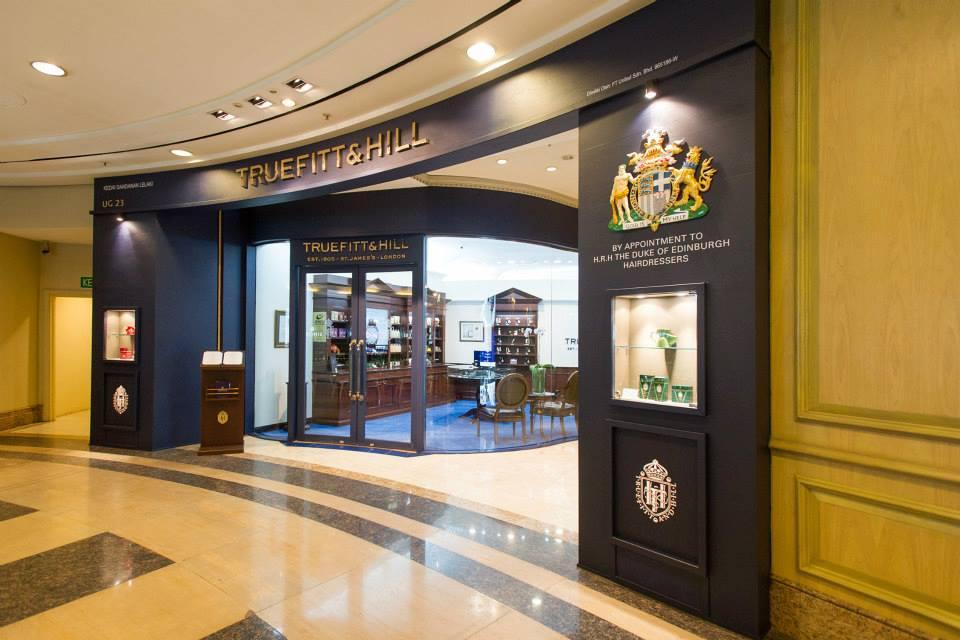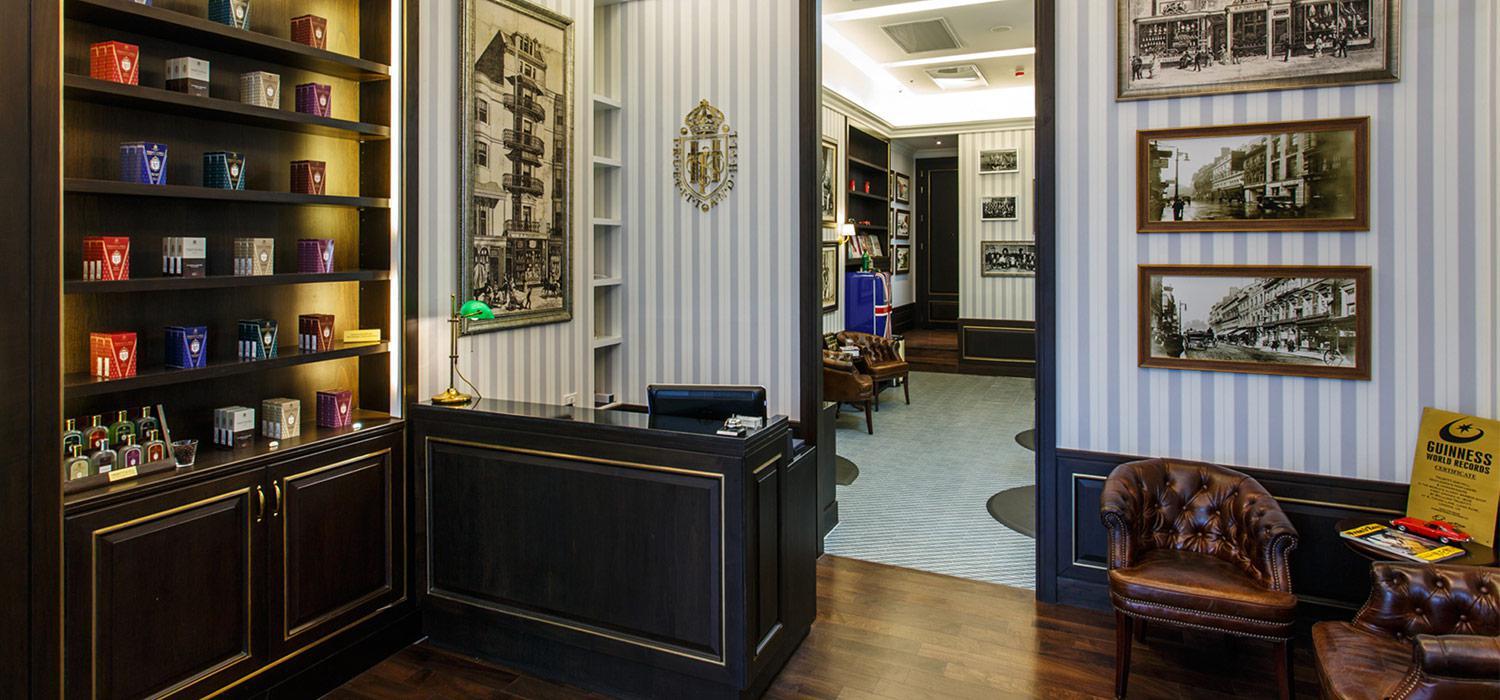The first image is the image on the left, the second image is the image on the right. For the images displayed, is the sentence "There are men in black vests working on a customer in a barber chair." factually correct? Answer yes or no. No. 